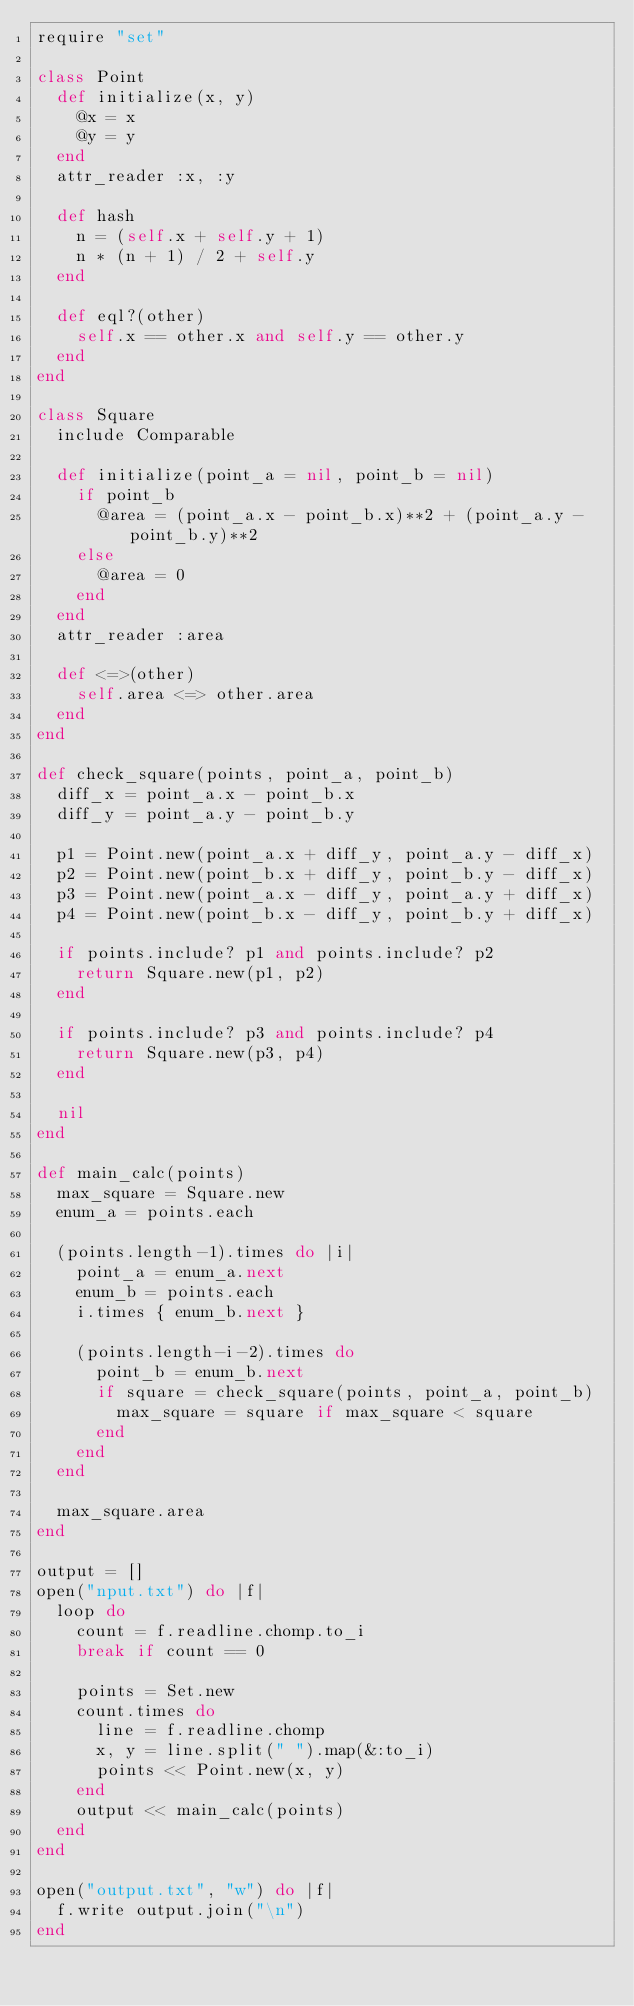Convert code to text. <code><loc_0><loc_0><loc_500><loc_500><_Ruby_>require "set"

class Point
  def initialize(x, y)
    @x = x
    @y = y
  end
  attr_reader :x, :y

  def hash
    n = (self.x + self.y + 1)
    n * (n + 1) / 2 + self.y
  end

  def eql?(other)
    self.x == other.x and self.y == other.y
  end
end

class Square
  include Comparable

  def initialize(point_a = nil, point_b = nil)
    if point_b
      @area = (point_a.x - point_b.x)**2 + (point_a.y - point_b.y)**2
    else
      @area = 0
    end
  end
  attr_reader :area

  def <=>(other)
    self.area <=> other.area
  end
end

def check_square(points, point_a, point_b)
  diff_x = point_a.x - point_b.x
  diff_y = point_a.y - point_b.y

  p1 = Point.new(point_a.x + diff_y, point_a.y - diff_x)
  p2 = Point.new(point_b.x + diff_y, point_b.y - diff_x)
  p3 = Point.new(point_a.x - diff_y, point_a.y + diff_x)
  p4 = Point.new(point_b.x - diff_y, point_b.y + diff_x)

  if points.include? p1 and points.include? p2
    return Square.new(p1, p2)
  end

  if points.include? p3 and points.include? p4
    return Square.new(p3, p4)
  end

  nil
end

def main_calc(points)
  max_square = Square.new
  enum_a = points.each

  (points.length-1).times do |i|
    point_a = enum_a.next
    enum_b = points.each
    i.times { enum_b.next }

    (points.length-i-2).times do
      point_b = enum_b.next
      if square = check_square(points, point_a, point_b)
        max_square = square if max_square < square
      end
    end
  end

  max_square.area
end

output = []
open("nput.txt") do |f|
  loop do 
    count = f.readline.chomp.to_i
    break if count == 0

    points = Set.new
    count.times do
      line = f.readline.chomp
      x, y = line.split(" ").map(&:to_i)
      points << Point.new(x, y)
    end
    output << main_calc(points) 
  end
end

open("output.txt", "w") do |f|
  f.write output.join("\n")
end</code> 